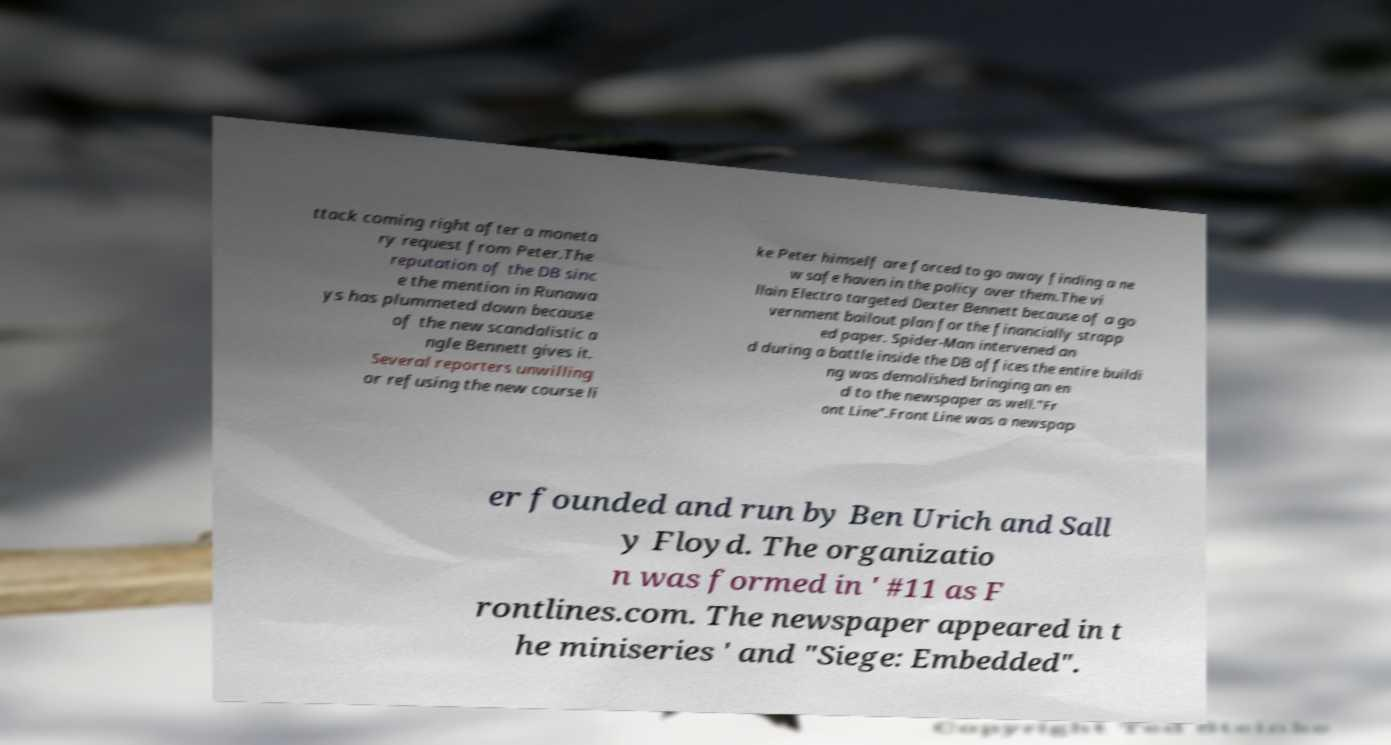Please read and relay the text visible in this image. What does it say? ttack coming right after a moneta ry request from Peter.The reputation of the DB sinc e the mention in Runawa ys has plummeted down because of the new scandalistic a ngle Bennett gives it. Several reporters unwilling or refusing the new course li ke Peter himself are forced to go away finding a ne w safe haven in the policy over them.The vi llain Electro targeted Dexter Bennett because of a go vernment bailout plan for the financially strapp ed paper. Spider-Man intervened an d during a battle inside the DB offices the entire buildi ng was demolished bringing an en d to the newspaper as well."Fr ont Line".Front Line was a newspap er founded and run by Ben Urich and Sall y Floyd. The organizatio n was formed in ' #11 as F rontlines.com. The newspaper appeared in t he miniseries ' and "Siege: Embedded". 